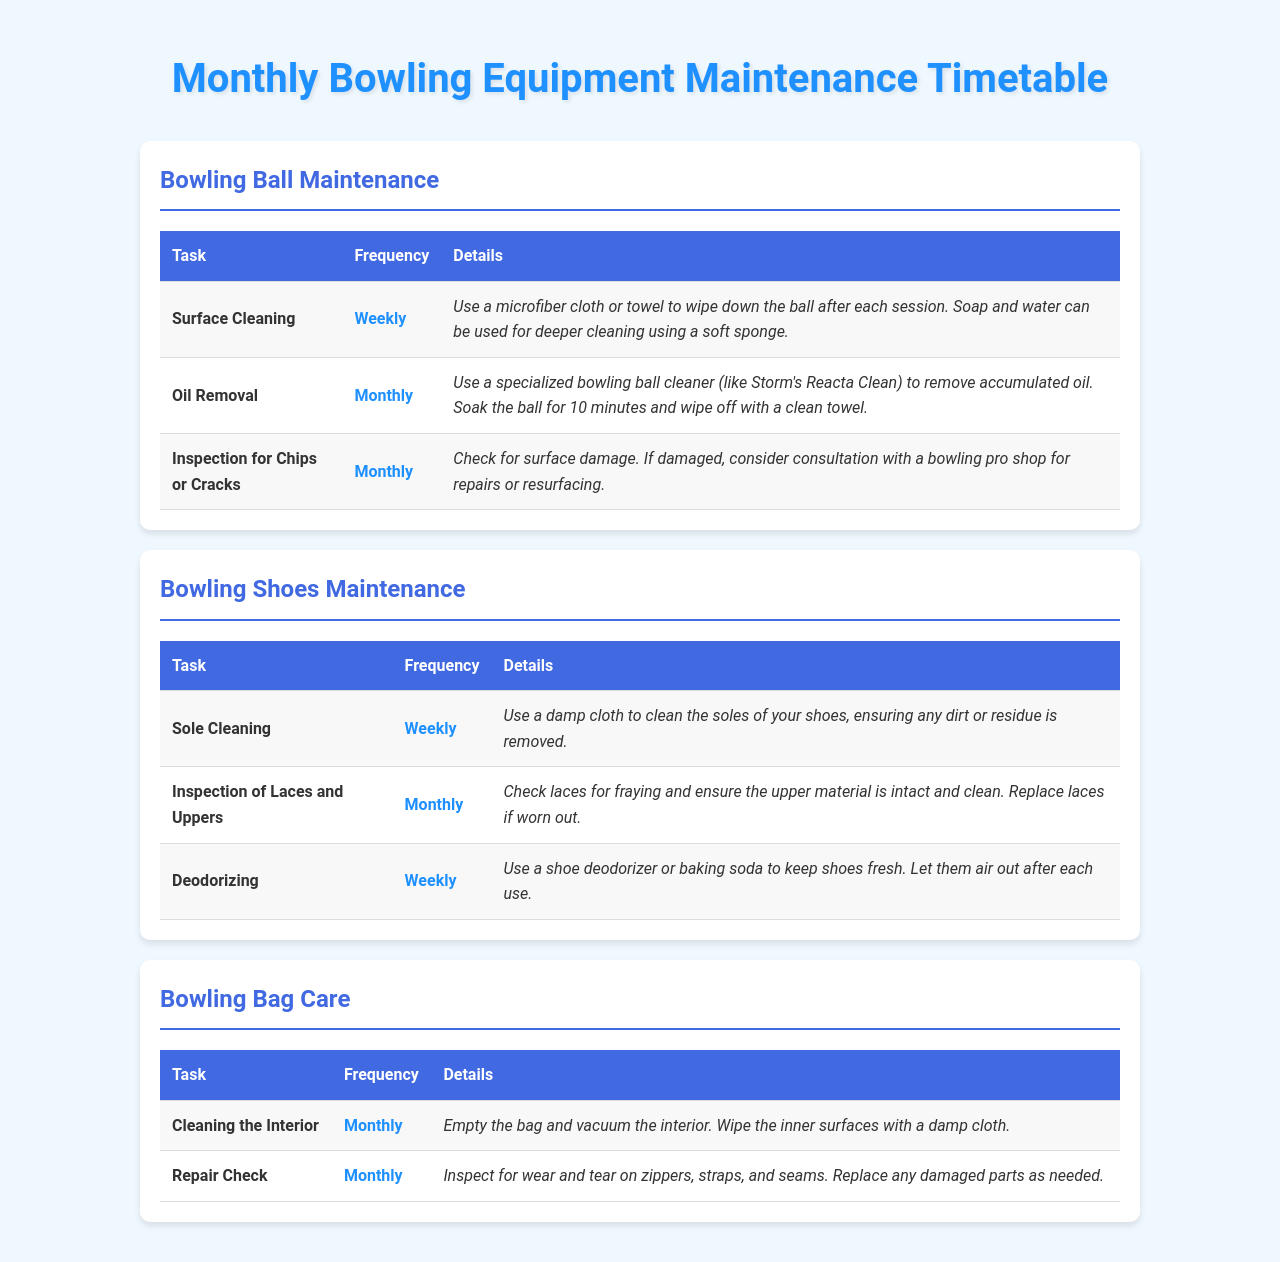What is the task for bowling ball surface cleaning? The task for bowling ball surface cleaning is listed under "Bowling Ball Maintenance" in the document. It states: "Surface Cleaning."
Answer: Surface Cleaning How often should you remove oil from the bowling ball? The frequency is specified in the table under "Bowling Ball Maintenance," stating it is to be done monthly.
Answer: Monthly What should you check on bowling shoes every month? The document mentions an inspection task in "Bowling Shoes Maintenance," which is "Inspection of Laces and Uppers."
Answer: Inspection of Laces and Uppers What is the frequency for deodorizing bowling shoes? This information is found under "Bowling Shoes Maintenance," where it states the frequency for deodorizing is weekly.
Answer: Weekly How should you clean the interior of the bowling bag? The cleaning method is detailed in "Bowling Bag Care," specifying to "vacuum the interior" and "wipe the inner surfaces with a damp cloth."
Answer: Vacuum and wipe What type of cleaning is required for the bowling ball after each session? This detail is under "Bowling Ball Maintenance," indicating that it is "Surface Cleaning" that should be done after each session.
Answer: Surface Cleaning What action should you take if the bowling ball has surface damage? The document suggests consulting with a bowling pro shop for repairs or resurfacing if there are chips or cracks found.
Answer: Consult a bowling pro shop What is the task listed for cleaning bowling shoes? The task related to shoes is found under "Bowling Shoes Maintenance," labeled as "Sole Cleaning."
Answer: Sole Cleaning What is the main task for checking the bowling bag monthly? Under "Bowling Bag Care," the main task listed is "Repair Check."
Answer: Repair Check 